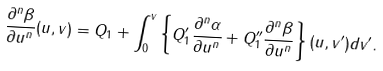<formula> <loc_0><loc_0><loc_500><loc_500>\frac { \partial ^ { n } \beta } { \partial u ^ { n } } ( u , v ) = Q _ { 1 } + \int _ { 0 } ^ { v } \left \{ Q _ { 1 } ^ { \prime } \frac { \partial ^ { n } \alpha } { \partial u ^ { n } } + Q _ { 1 } ^ { \prime \prime } \frac { \partial ^ { n } \beta } { \partial u ^ { n } } \right \} ( u , v ^ { \prime } ) d v ^ { \prime } .</formula> 